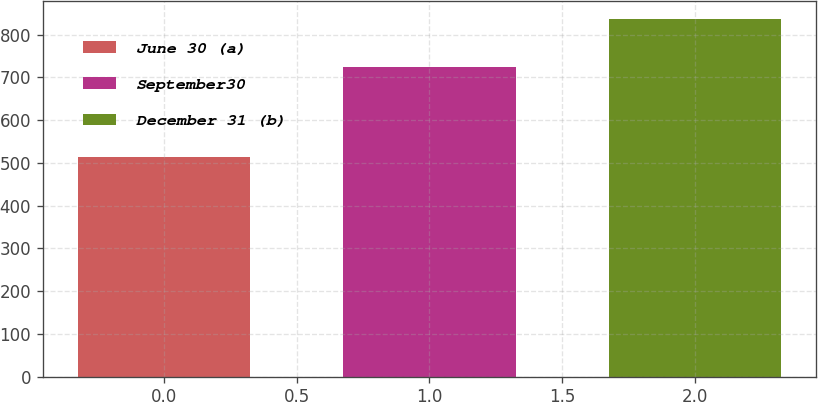Convert chart to OTSL. <chart><loc_0><loc_0><loc_500><loc_500><bar_chart><fcel>June 30 (a)<fcel>September30<fcel>December 31 (b)<nl><fcel>514<fcel>725<fcel>837<nl></chart> 